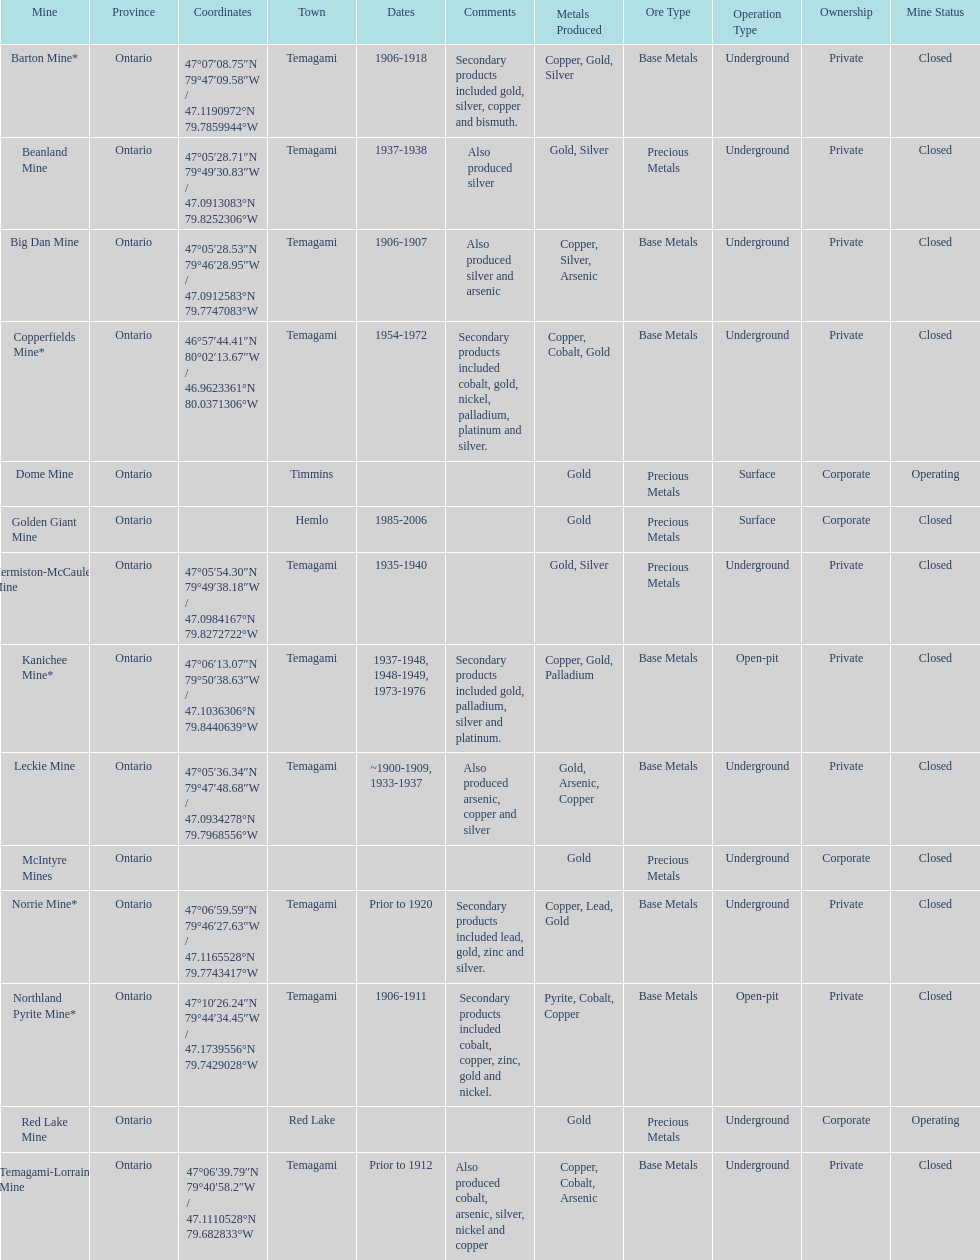Identify a gold mine that has been operational for a minimum of 10 years. Barton Mine. Would you mind parsing the complete table? {'header': ['Mine', 'Province', 'Coordinates', 'Town', 'Dates', 'Comments', 'Metals Produced', 'Ore Type', 'Operation Type', 'Ownership', 'Mine Status'], 'rows': [['Barton Mine*', 'Ontario', '47°07′08.75″N 79°47′09.58″W\ufeff / \ufeff47.1190972°N 79.7859944°W', 'Temagami', '1906-1918', 'Secondary products included gold, silver, copper and bismuth.', 'Copper, Gold, Silver', 'Base Metals', 'Underground', 'Private', 'Closed'], ['Beanland Mine', 'Ontario', '47°05′28.71″N 79°49′30.83″W\ufeff / \ufeff47.0913083°N 79.8252306°W', 'Temagami', '1937-1938', 'Also produced silver', 'Gold, Silver', 'Precious Metals', 'Underground', 'Private', 'Closed'], ['Big Dan Mine', 'Ontario', '47°05′28.53″N 79°46′28.95″W\ufeff / \ufeff47.0912583°N 79.7747083°W', 'Temagami', '1906-1907', 'Also produced silver and arsenic', 'Copper, Silver, Arsenic', 'Base Metals', 'Underground', 'Private', 'Closed'], ['Copperfields Mine*', 'Ontario', '46°57′44.41″N 80°02′13.67″W\ufeff / \ufeff46.9623361°N 80.0371306°W', 'Temagami', '1954-1972', 'Secondary products included cobalt, gold, nickel, palladium, platinum and silver.', 'Copper, Cobalt, Gold', 'Base Metals', 'Underground', 'Private', 'Closed'], ['Dome Mine', 'Ontario', '', 'Timmins', '', '', 'Gold', 'Precious Metals', 'Surface', 'Corporate', 'Operating'], ['Golden Giant Mine', 'Ontario', '', 'Hemlo', '1985-2006', '', 'Gold', 'Precious Metals', 'Surface', 'Corporate', 'Closed'], ['Hermiston-McCauley Mine', 'Ontario', '47°05′54.30″N 79°49′38.18″W\ufeff / \ufeff47.0984167°N 79.8272722°W', 'Temagami', '1935-1940', '', 'Gold, Silver', 'Precious Metals', 'Underground', 'Private', 'Closed'], ['Kanichee Mine*', 'Ontario', '47°06′13.07″N 79°50′38.63″W\ufeff / \ufeff47.1036306°N 79.8440639°W', 'Temagami', '1937-1948, 1948-1949, 1973-1976', 'Secondary products included gold, palladium, silver and platinum.', 'Copper, Gold, Palladium', 'Base Metals', 'Open-pit', 'Private', 'Closed'], ['Leckie Mine', 'Ontario', '47°05′36.34″N 79°47′48.68″W\ufeff / \ufeff47.0934278°N 79.7968556°W', 'Temagami', '~1900-1909, 1933-1937', 'Also produced arsenic, copper and silver', 'Gold, Arsenic, Copper', 'Base Metals', 'Underground', 'Private', 'Closed'], ['McIntyre Mines', 'Ontario', '', '', '', '', 'Gold', 'Precious Metals', 'Underground', 'Corporate', 'Closed'], ['Norrie Mine*', 'Ontario', '47°06′59.59″N 79°46′27.63″W\ufeff / \ufeff47.1165528°N 79.7743417°W', 'Temagami', 'Prior to 1920', 'Secondary products included lead, gold, zinc and silver.', 'Copper, Lead, Gold', 'Base Metals', 'Underground', 'Private', 'Closed'], ['Northland Pyrite Mine*', 'Ontario', '47°10′26.24″N 79°44′34.45″W\ufeff / \ufeff47.1739556°N 79.7429028°W', 'Temagami', '1906-1911', 'Secondary products included cobalt, copper, zinc, gold and nickel.', 'Pyrite, Cobalt, Copper', 'Base Metals', 'Open-pit', 'Private', 'Closed'], ['Red Lake Mine', 'Ontario', '', 'Red Lake', '', '', 'Gold', 'Precious Metals', 'Underground', 'Corporate', 'Operating'], ['Temagami-Lorrain Mine', 'Ontario', '47°06′39.79″N 79°40′58.2″W\ufeff / \ufeff47.1110528°N 79.682833°W', 'Temagami', 'Prior to 1912', 'Also produced cobalt, arsenic, silver, nickel and copper', 'Copper, Cobalt, Arsenic', 'Base Metals', 'Underground', 'Private', 'Closed']]} 